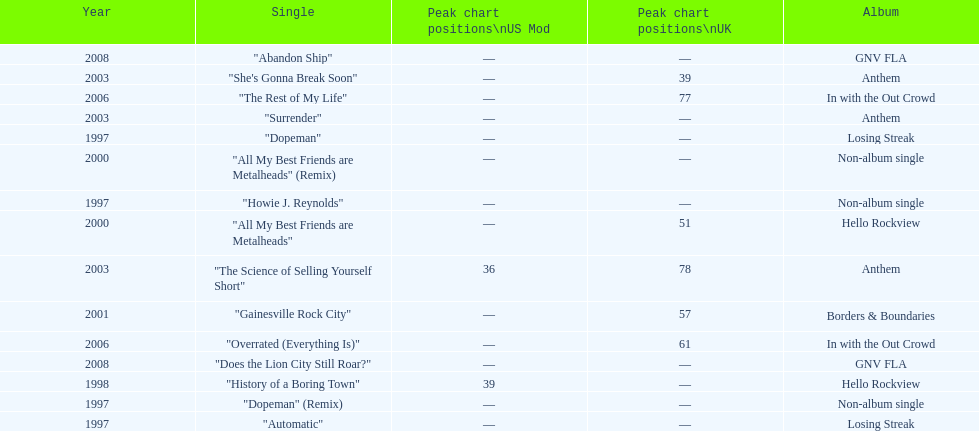Compare the chart positions between the us and the uk for the science of selling yourself short, where did it do better? US. 